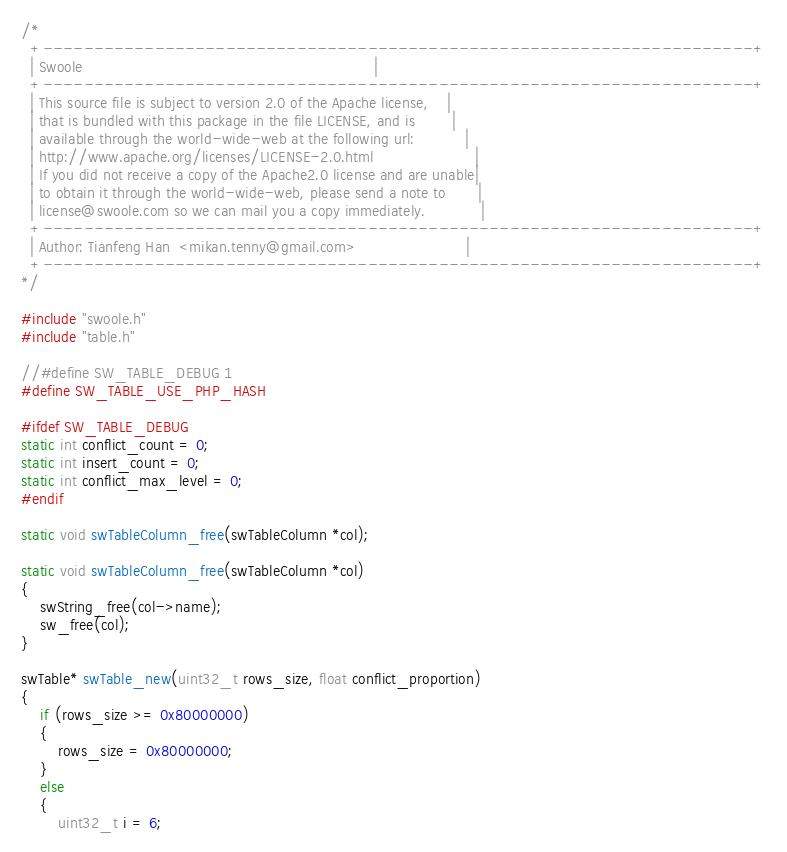<code> <loc_0><loc_0><loc_500><loc_500><_C_>/*
  +----------------------------------------------------------------------+
  | Swoole                                                               |
  +----------------------------------------------------------------------+
  | This source file is subject to version 2.0 of the Apache license,    |
  | that is bundled with this package in the file LICENSE, and is        |
  | available through the world-wide-web at the following url:           |
  | http://www.apache.org/licenses/LICENSE-2.0.html                      |
  | If you did not receive a copy of the Apache2.0 license and are unable|
  | to obtain it through the world-wide-web, please send a note to       |
  | license@swoole.com so we can mail you a copy immediately.            |
  +----------------------------------------------------------------------+
  | Author: Tianfeng Han  <mikan.tenny@gmail.com>                        |
  +----------------------------------------------------------------------+
*/

#include "swoole.h"
#include "table.h"

//#define SW_TABLE_DEBUG 1
#define SW_TABLE_USE_PHP_HASH

#ifdef SW_TABLE_DEBUG
static int conflict_count = 0;
static int insert_count = 0;
static int conflict_max_level = 0;
#endif

static void swTableColumn_free(swTableColumn *col);

static void swTableColumn_free(swTableColumn *col)
{
    swString_free(col->name);
    sw_free(col);
}

swTable* swTable_new(uint32_t rows_size, float conflict_proportion)
{
    if (rows_size >= 0x80000000)
    {
        rows_size = 0x80000000;
    }
    else
    {
        uint32_t i = 6;</code> 